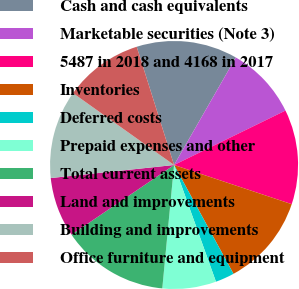<chart> <loc_0><loc_0><loc_500><loc_500><pie_chart><fcel>Cash and cash equivalents<fcel>Marketable securities (Note 3)<fcel>5487 in 2018 and 4168 in 2017<fcel>Inventories<fcel>Deferred costs<fcel>Prepaid expenses and other<fcel>Total current assets<fcel>Land and improvements<fcel>Building and improvements<fcel>Office furniture and equipment<nl><fcel>13.17%<fcel>9.47%<fcel>12.35%<fcel>11.93%<fcel>2.47%<fcel>7.0%<fcel>13.99%<fcel>7.82%<fcel>11.52%<fcel>10.29%<nl></chart> 